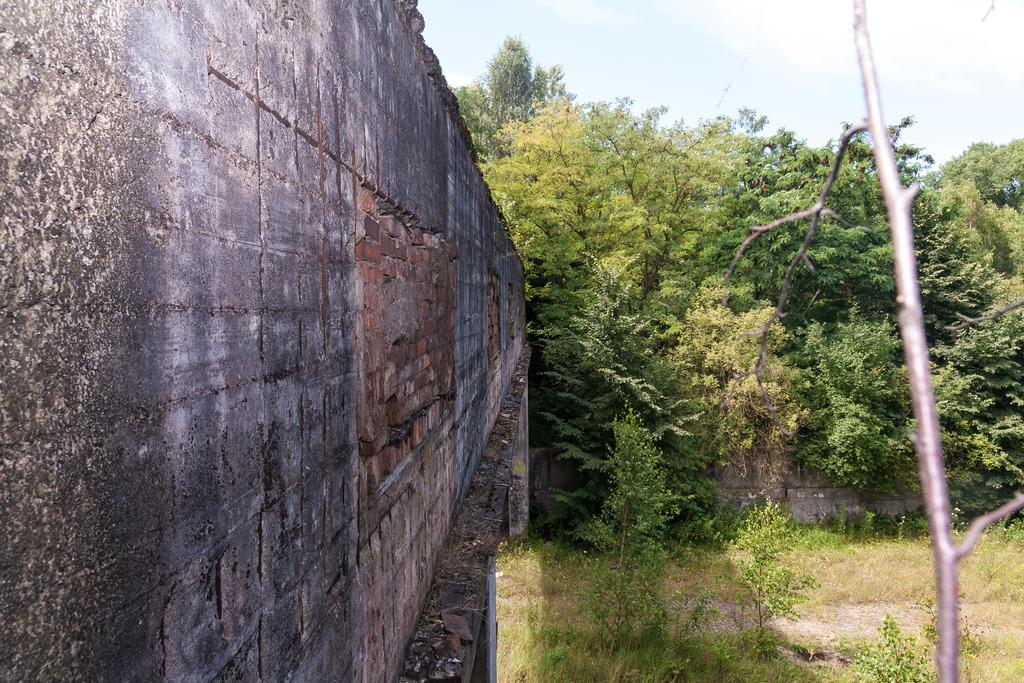What is the main structure visible in the image? There is a wall in the image. What type of vegetation is present near the wall? There are trees beside the wall. What type of surface is visible in the image? There is grass on the surface in the image. What is the position of the moon in the image? There is no moon visible in the image; it is focused on a wall, trees, and grass. 